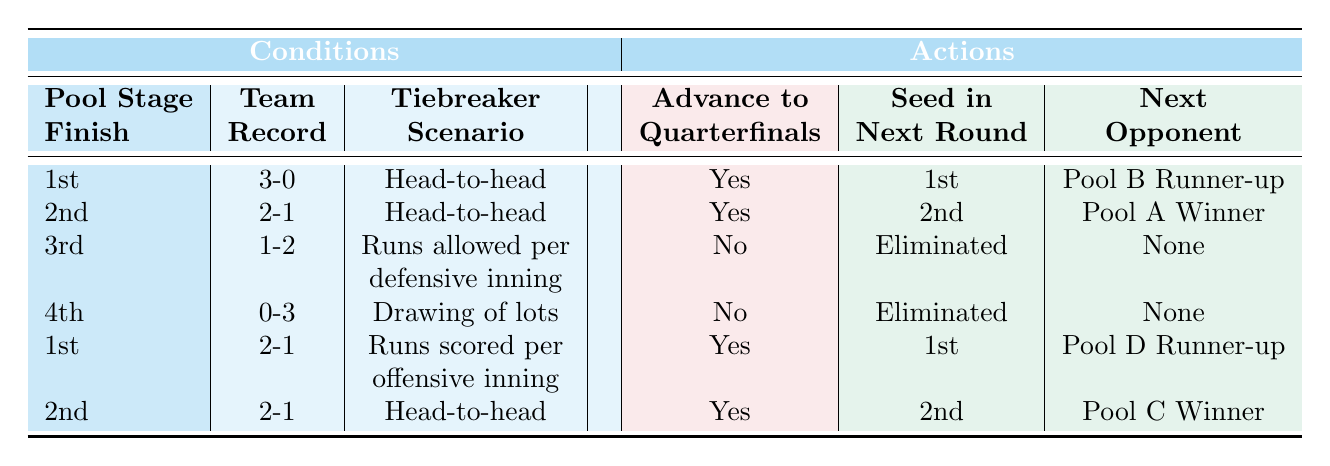What happens if a team finishes 1st with a 2-1 record and the tiebreaker is based on runs scored per offensive inning? According to the table, if a team finishes 1st with a 2-1 record and uses runs scored per offensive inning as the tiebreaker, they will advance to the quarterfinals, be seeded 1st, and face the Pool D Runner-up as their next opponent.
Answer: Yes, 1st, Pool D Runner-up If a team finishes 4th with a record of 0-3, do they advance to the quarterfinals? The table indicates that a team finishing 4th with an 0-3 record will not advance to the quarterfinals and will be eliminated regardless of the tiebreaker used.
Answer: No What is the next opponent for a team that finishes 2nd with a record of 2-1 and the tiebreaker is head-to-head? From the table, a team finishing 2nd with a 2-1 record and the tiebreaker being head-to-head will advance to the quarterfinals as the 2nd seed and will face the Pool C Winner as their next opponent.
Answer: Pool C Winner How many teams advance to the quarterfinals if they finish 1st with a 3-0 record and use a head-to-head tiebreaker? The table shows that if a team finishes 1st with a 3-0 record and the tiebreaker is head-to-head, they will advance to the quarterfinals. Thus, only 1 team from this specific condition advances, but the context of the overall pool isn't provided in this specific question.
Answer: Yes If a team finishes 3rd with a record of 1-2 using runs allowed per defensive inning, do they advance or are they eliminated? According to the table, a team finishing in 3rd place with a record of 1-2 and using runs allowed per defensive inning as the tiebreaker will be eliminated and will not advance to the quarterfinals.
Answer: Eliminated What does a 2nd place finish with a 2-1 record using runs scored per offensive inning mean for a team's advancement? The table does not list this specific scenario directly, but one can deduce that if the team finished 2nd with a 2-1 record but is not specifically highlighted for that tiebreaker, it defaults to other previously listed configurations, mainly head-to-head or defensive metrics, which may have been more relevant. Thus, technically they could advance, but further specifics on the fourth criterion can alter results.
Answer: Unknown Which seed position can a team expect to have if they finish in 1st place with a 3-0 record and the tiebreaker is head-to-head? For a team finishing 1st with a 3-0 record using the head-to-head tiebreaker, the table states they will be seeded 1st in the next round.
Answer: 1st 